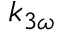Convert formula to latex. <formula><loc_0><loc_0><loc_500><loc_500>k _ { 3 \omega }</formula> 